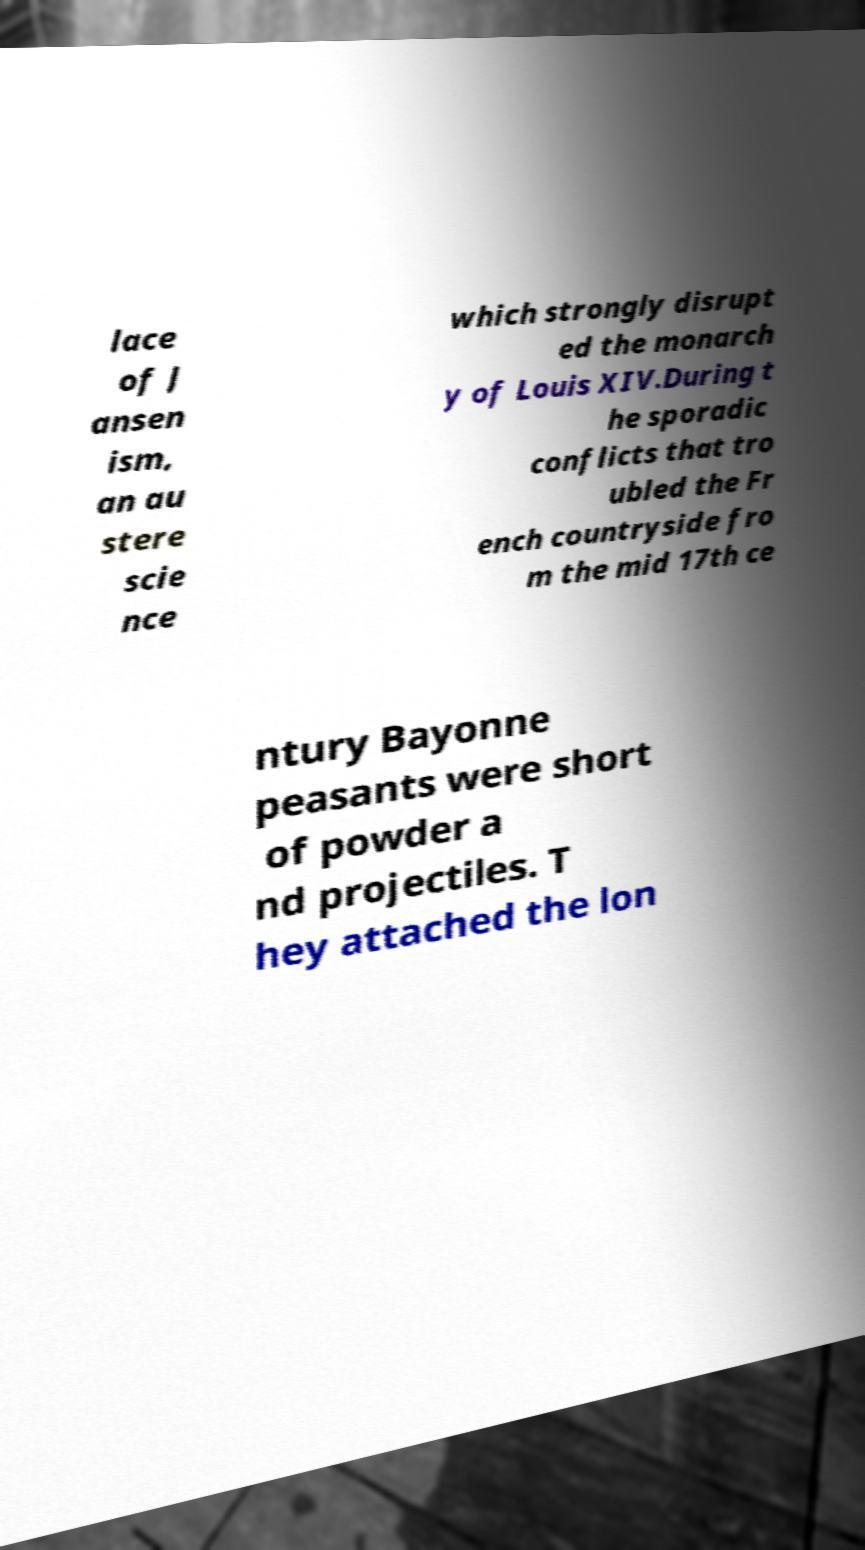Please identify and transcribe the text found in this image. lace of J ansen ism, an au stere scie nce which strongly disrupt ed the monarch y of Louis XIV.During t he sporadic conflicts that tro ubled the Fr ench countryside fro m the mid 17th ce ntury Bayonne peasants were short of powder a nd projectiles. T hey attached the lon 